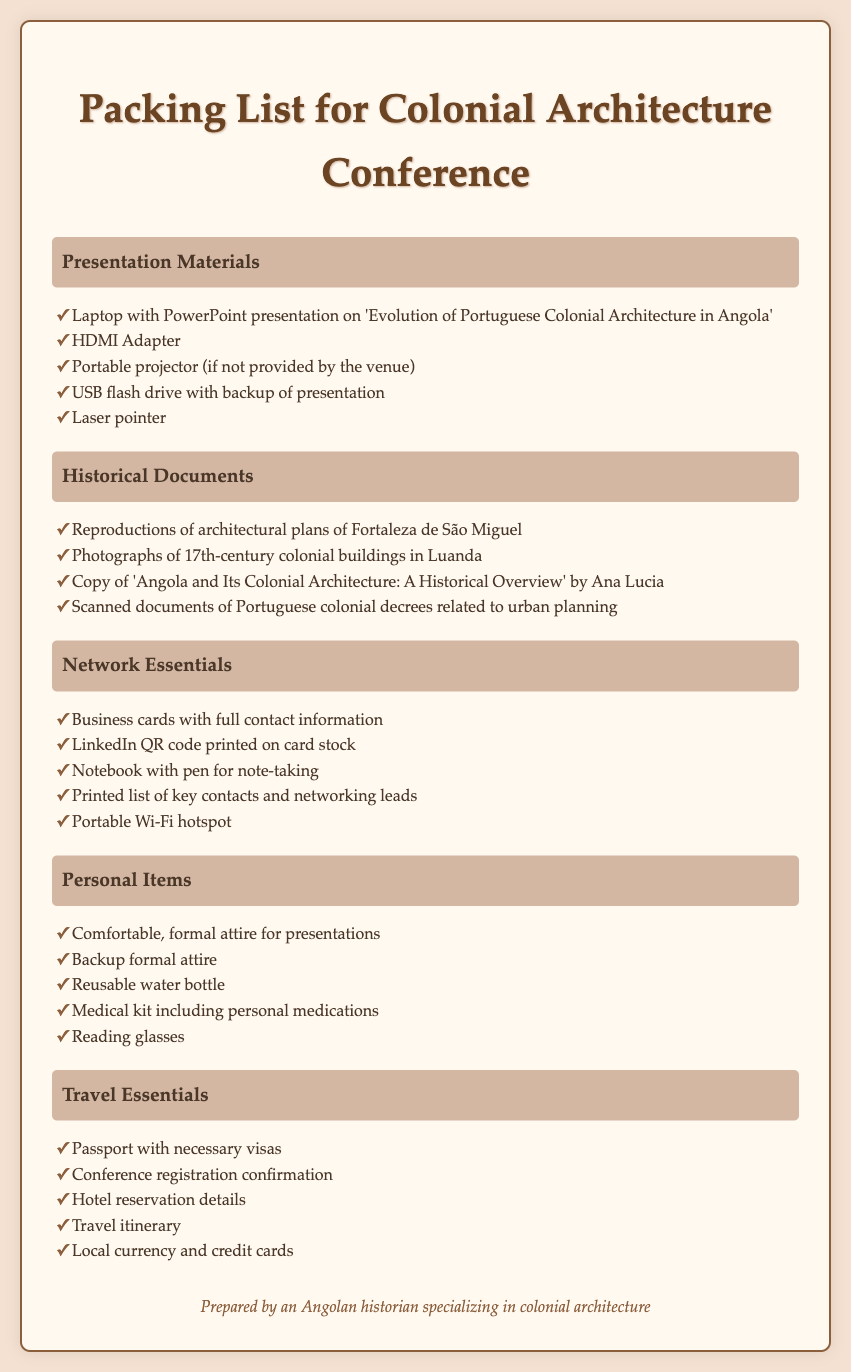What is the title of the presentation on the laptop? The title of the presentation is specified in the list under Presentation Materials in the document.
Answer: Evolution of Portuguese Colonial Architecture in Angola How many items are listed under Historical Documents? The count of items can be determined by counting the bullet points in the Historical Documents category.
Answer: Four What is one networking essential mentioned? You can find specific networking essentials listed under the Network Essentials category in the document.
Answer: Business cards with full contact information What type of attire is suggested for presentations? The suggested attire is found in the Personal Items category, specifically referring to what is appropriate for presentations.
Answer: Comfortable, formal attire What document confirms conference registration? The document confirming attendance is mentioned in the Travel Essentials category.
Answer: Conference registration confirmation What item is needed for note-taking? The item needed for note-taking can be found listed in the Network Essentials category.
Answer: Notebook with pen for note-taking How many categories are there in the packing list? The number of categories can be identified by counting the main section headings in the document.
Answer: Five What is included in the Medical kit? The specific items to be included can be found under Personal Items in the document.
Answer: Personal medications What is required alongside the passport for travel? The item required with the passport can be found in the Travel Essentials section.
Answer: Necessary visas 